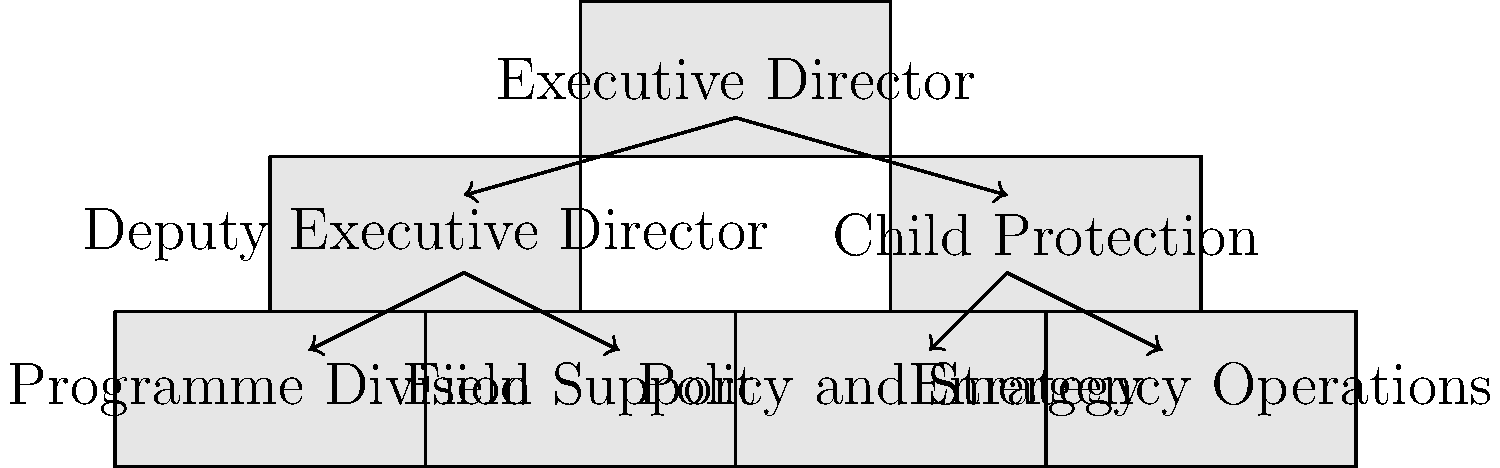Based on the organizational chart of UNICEF's child protection division, which unit is directly responsible for developing policies and strategies related to child protection? To answer this question, let's analyze the organizational chart step-by-step:

1. At the top of the chart, we see the "Executive Director" of UNICEF.

2. Directly below the Executive Director, there are two main branches:
   a) Deputy Executive Director
   b) Child Protection

3. The Child Protection branch, which is our focus, has four sub-units:
   a) Programme Division
   b) Field Support
   c) Policy and Strategy
   d) Emergency Operations

4. Among these sub-units, we need to identify which one is responsible for developing policies and strategies related to child protection.

5. The unit labeled "Policy and Strategy" is clearly the one tasked with this responsibility, as its name directly indicates its role in developing policies and strategies.

6. This aligns with UNICEF's structure, where the Policy and Strategy unit within the Child Protection division would be responsible for formulating and developing policies and strategic approaches to protect children's rights and well-being globally.

Therefore, based on the organizational chart, the unit directly responsible for developing policies and strategies related to child protection is the Policy and Strategy unit.
Answer: Policy and Strategy 